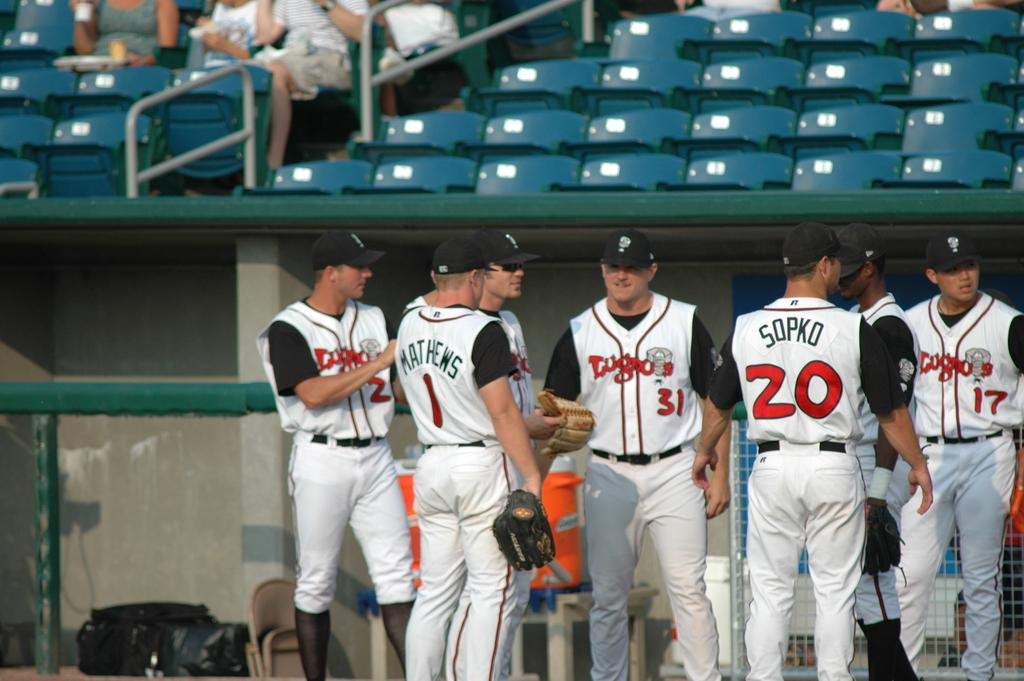<image>
Share a concise interpretation of the image provided. A group of basketball players are standing in the dugout and wearing Lugnuts jerseys. 